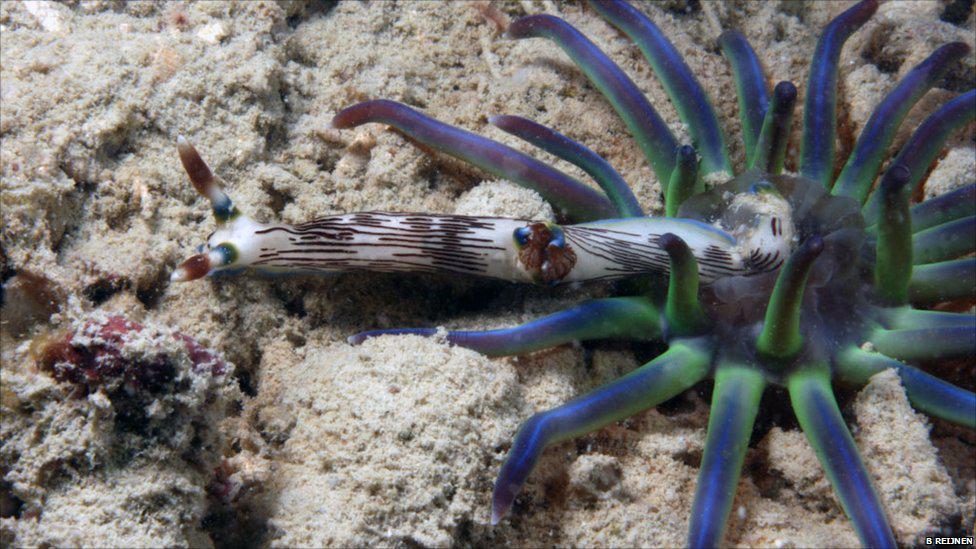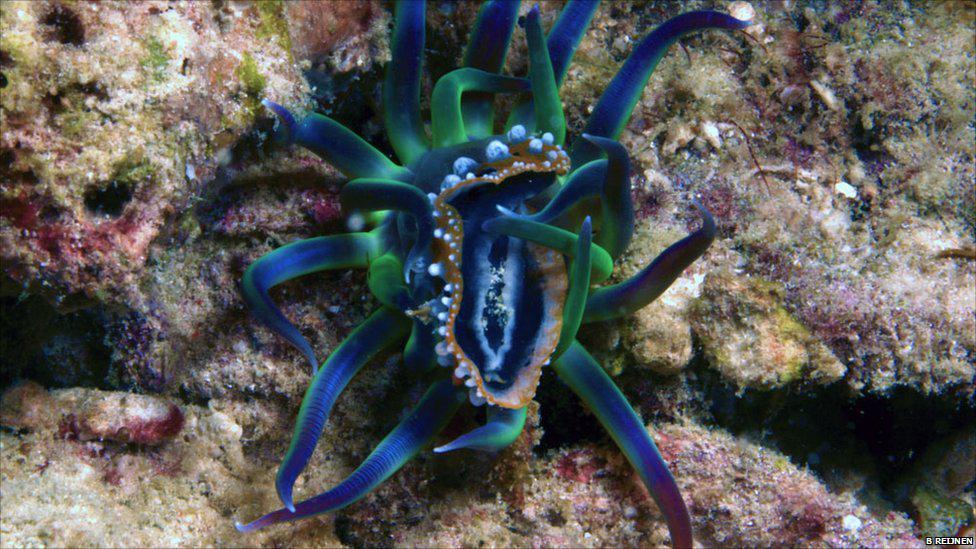The first image is the image on the left, the second image is the image on the right. Considering the images on both sides, is "An anemone of green, blue, and purple sits on the sandy floor, eating." valid? Answer yes or no. Yes. The first image is the image on the left, the second image is the image on the right. Evaluate the accuracy of this statement regarding the images: "In the right image, the sea slug has blue-ish arms/tentacles.". Is it true? Answer yes or no. Yes. 